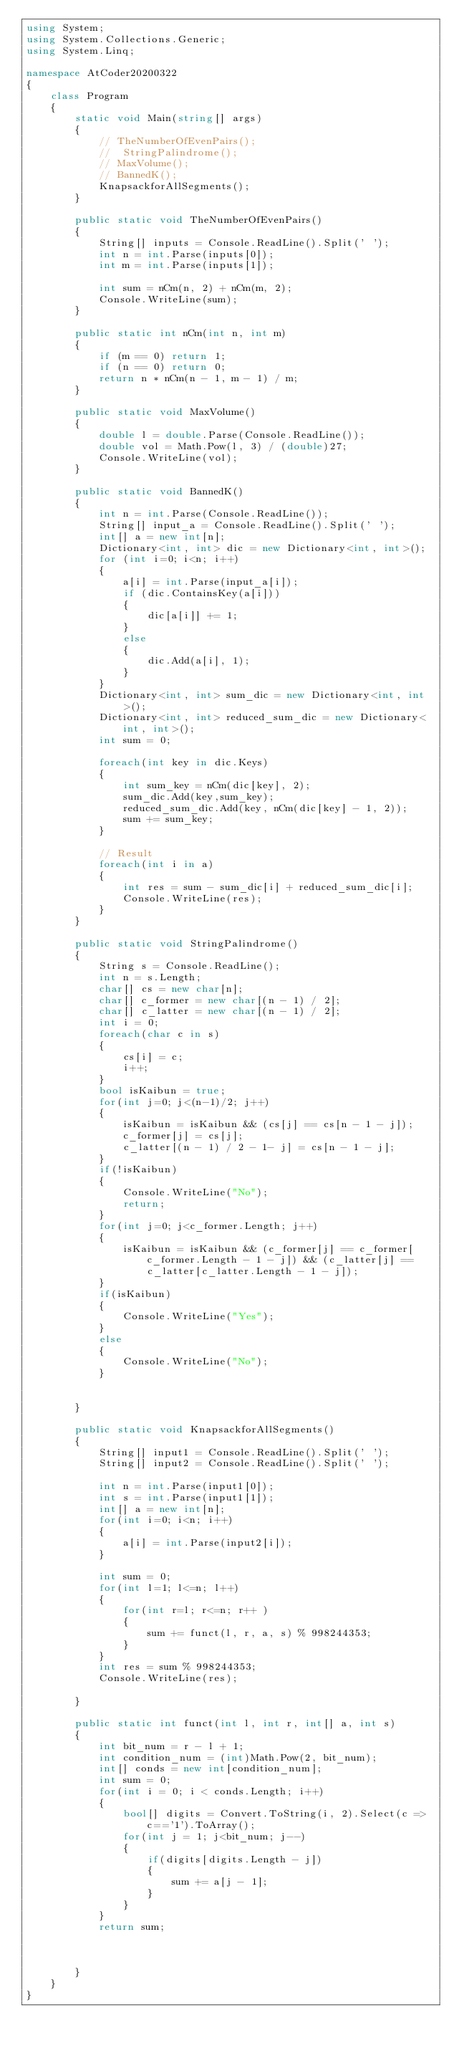<code> <loc_0><loc_0><loc_500><loc_500><_C#_>using System;
using System.Collections.Generic;
using System.Linq;

namespace AtCoder20200322
{
    class Program
    {
        static void Main(string[] args)
        {
            // TheNumberOfEvenPairs();
            //  StringPalindrome();
            // MaxVolume();
            // BannedK();
            KnapsackforAllSegments();
        }
        
        public static void TheNumberOfEvenPairs()
        {
            String[] inputs = Console.ReadLine().Split(' ');
            int n = int.Parse(inputs[0]);
            int m = int.Parse(inputs[1]);

            int sum = nCm(n, 2) + nCm(m, 2);
            Console.WriteLine(sum);
        }

        public static int nCm(int n, int m)
        {
            if (m == 0) return 1;
            if (n == 0) return 0;
            return n * nCm(n - 1, m - 1) / m;
        }

        public static void MaxVolume()
        {
            double l = double.Parse(Console.ReadLine());
            double vol = Math.Pow(l, 3) / (double)27;
            Console.WriteLine(vol);
        }

        public static void BannedK()
        {
            int n = int.Parse(Console.ReadLine());
            String[] input_a = Console.ReadLine().Split(' ');
            int[] a = new int[n];
            Dictionary<int, int> dic = new Dictionary<int, int>();
            for (int i=0; i<n; i++)
            {
                a[i] = int.Parse(input_a[i]);
                if (dic.ContainsKey(a[i]))
                {
                    dic[a[i]] += 1;
                }
                else
                {
                    dic.Add(a[i], 1);
                }
            }
            Dictionary<int, int> sum_dic = new Dictionary<int, int>();
            Dictionary<int, int> reduced_sum_dic = new Dictionary<int, int>();
            int sum = 0;
            
            foreach(int key in dic.Keys)
            {
                int sum_key = nCm(dic[key], 2);
                sum_dic.Add(key,sum_key);
                reduced_sum_dic.Add(key, nCm(dic[key] - 1, 2));
                sum += sum_key;
            }

            // Result
            foreach(int i in a)
            {
                int res = sum - sum_dic[i] + reduced_sum_dic[i];
                Console.WriteLine(res);
            }
        }

        public static void StringPalindrome()
        {
            String s = Console.ReadLine();
            int n = s.Length;
            char[] cs = new char[n];
            char[] c_former = new char[(n - 1) / 2];
            char[] c_latter = new char[(n - 1) / 2];
            int i = 0;
            foreach(char c in s)
            {
                cs[i] = c;
                i++;
            }
            bool isKaibun = true;
            for(int j=0; j<(n-1)/2; j++)
            {
                isKaibun = isKaibun && (cs[j] == cs[n - 1 - j]);
                c_former[j] = cs[j];
                c_latter[(n - 1) / 2 - 1- j] = cs[n - 1 - j];
            }
            if(!isKaibun)
            {
                Console.WriteLine("No");
                return;
            }
            for(int j=0; j<c_former.Length; j++)
            {
                isKaibun = isKaibun && (c_former[j] == c_former[c_former.Length - 1 - j]) && (c_latter[j] == c_latter[c_latter.Length - 1 - j]);   
            }
            if(isKaibun)
            {
                Console.WriteLine("Yes");
            }
            else
            {
                Console.WriteLine("No");
            }


        }

        public static void KnapsackforAllSegments()
        {
            String[] input1 = Console.ReadLine().Split(' ');
            String[] input2 = Console.ReadLine().Split(' ');

            int n = int.Parse(input1[0]);
            int s = int.Parse(input1[1]);
            int[] a = new int[n];
            for(int i=0; i<n; i++)
            {
                a[i] = int.Parse(input2[i]);
            }

            int sum = 0;
            for(int l=1; l<=n; l++)
            {
                for(int r=l; r<=n; r++ )
                {
                    sum += funct(l, r, a, s) % 998244353;
                }
            }
            int res = sum % 998244353;
            Console.WriteLine(res);

        }

        public static int funct(int l, int r, int[] a, int s)
        {
            int bit_num = r - l + 1;
            int condition_num = (int)Math.Pow(2, bit_num);
            int[] conds = new int[condition_num];
            int sum = 0;
            for(int i = 0; i < conds.Length; i++)
            {
                bool[] digits = Convert.ToString(i, 2).Select(c => c=='1').ToArray();
                for(int j = 1; j<bit_num; j--)
                {
                    if(digits[digits.Length - j])
                    {
                        sum += a[j - 1];
                    }
                }
            }
            return sum;



        }
    }
}
</code> 